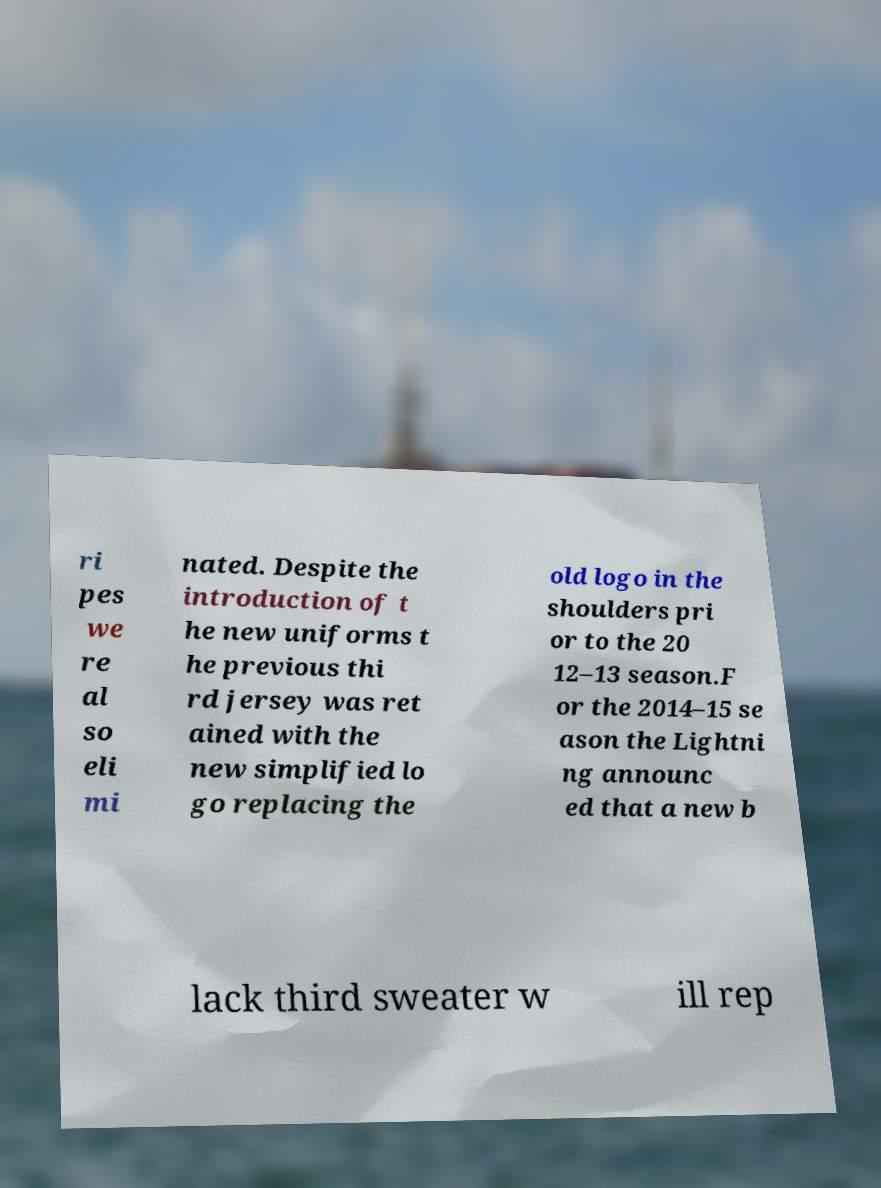Please read and relay the text visible in this image. What does it say? ri pes we re al so eli mi nated. Despite the introduction of t he new uniforms t he previous thi rd jersey was ret ained with the new simplified lo go replacing the old logo in the shoulders pri or to the 20 12–13 season.F or the 2014–15 se ason the Lightni ng announc ed that a new b lack third sweater w ill rep 